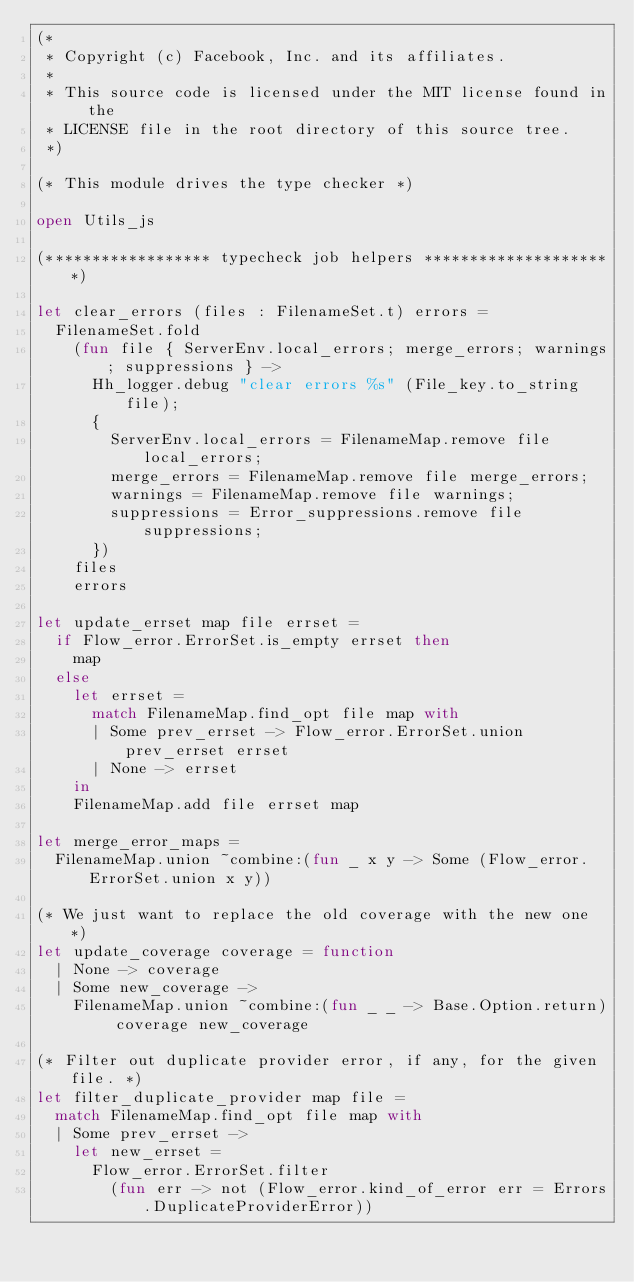Convert code to text. <code><loc_0><loc_0><loc_500><loc_500><_OCaml_>(*
 * Copyright (c) Facebook, Inc. and its affiliates.
 *
 * This source code is licensed under the MIT license found in the
 * LICENSE file in the root directory of this source tree.
 *)

(* This module drives the type checker *)

open Utils_js

(****************** typecheck job helpers *********************)

let clear_errors (files : FilenameSet.t) errors =
  FilenameSet.fold
    (fun file { ServerEnv.local_errors; merge_errors; warnings; suppressions } ->
      Hh_logger.debug "clear errors %s" (File_key.to_string file);
      {
        ServerEnv.local_errors = FilenameMap.remove file local_errors;
        merge_errors = FilenameMap.remove file merge_errors;
        warnings = FilenameMap.remove file warnings;
        suppressions = Error_suppressions.remove file suppressions;
      })
    files
    errors

let update_errset map file errset =
  if Flow_error.ErrorSet.is_empty errset then
    map
  else
    let errset =
      match FilenameMap.find_opt file map with
      | Some prev_errset -> Flow_error.ErrorSet.union prev_errset errset
      | None -> errset
    in
    FilenameMap.add file errset map

let merge_error_maps =
  FilenameMap.union ~combine:(fun _ x y -> Some (Flow_error.ErrorSet.union x y))

(* We just want to replace the old coverage with the new one *)
let update_coverage coverage = function
  | None -> coverage
  | Some new_coverage ->
    FilenameMap.union ~combine:(fun _ _ -> Base.Option.return) coverage new_coverage

(* Filter out duplicate provider error, if any, for the given file. *)
let filter_duplicate_provider map file =
  match FilenameMap.find_opt file map with
  | Some prev_errset ->
    let new_errset =
      Flow_error.ErrorSet.filter
        (fun err -> not (Flow_error.kind_of_error err = Errors.DuplicateProviderError))</code> 